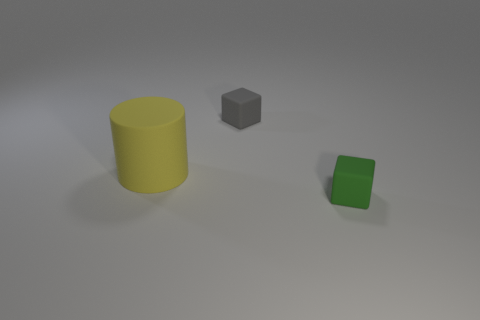What number of tiny green things have the same shape as the tiny gray matte object?
Your response must be concise. 1. There is a yellow object that is the same material as the green cube; what size is it?
Your answer should be very brief. Large. Does the green matte thing have the same size as the gray thing?
Provide a short and direct response. Yes. Are there any tiny blocks?
Give a very brief answer. Yes. How big is the matte block behind the tiny cube in front of the tiny rubber object behind the tiny green block?
Ensure brevity in your answer.  Small. How many large things have the same material as the big cylinder?
Offer a very short reply. 0. How many matte things have the same size as the green block?
Provide a short and direct response. 1. What is the material of the small thing that is behind the rubber object that is to the left of the tiny matte block that is behind the tiny green thing?
Provide a short and direct response. Rubber. How many things are either big blue cubes or gray things?
Offer a terse response. 1. Are there any other things that have the same material as the tiny green cube?
Your response must be concise. Yes. 